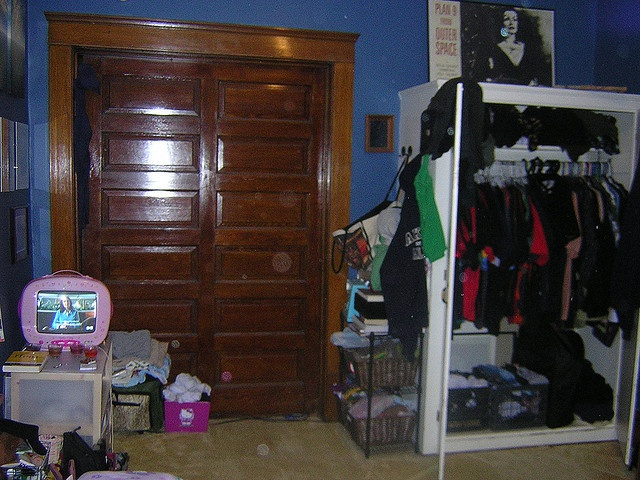Describe the objects in this image and their specific colors. I can see tv in gray, darkgray, violet, and white tones, backpack in gray, black, and darkgray tones, people in gray, black, and navy tones, book in gray, olive, darkgray, and black tones, and people in gray, white, and lightblue tones in this image. 